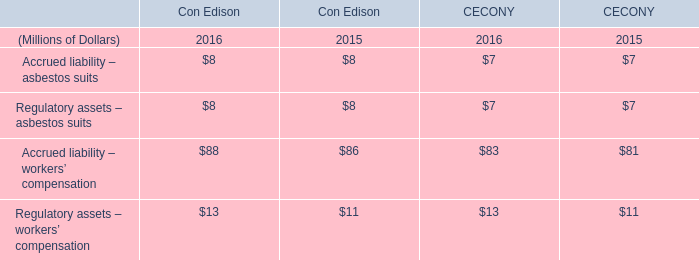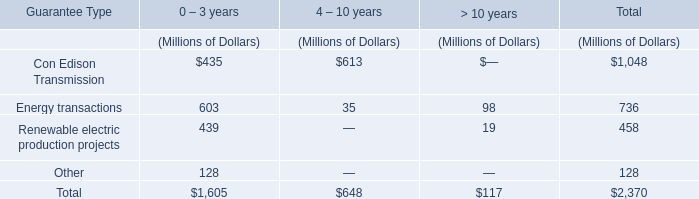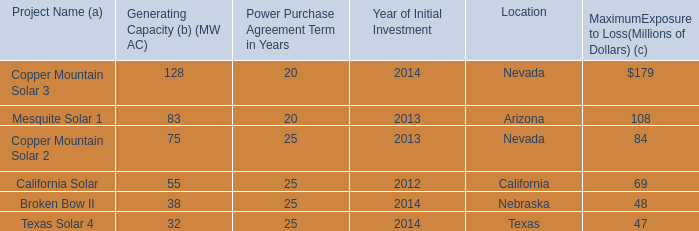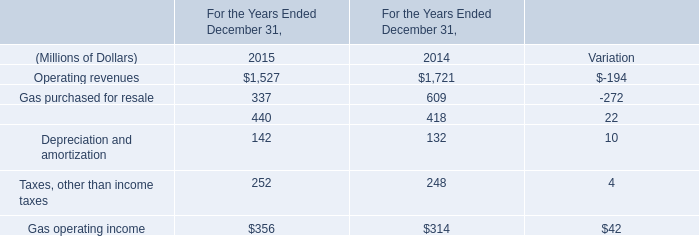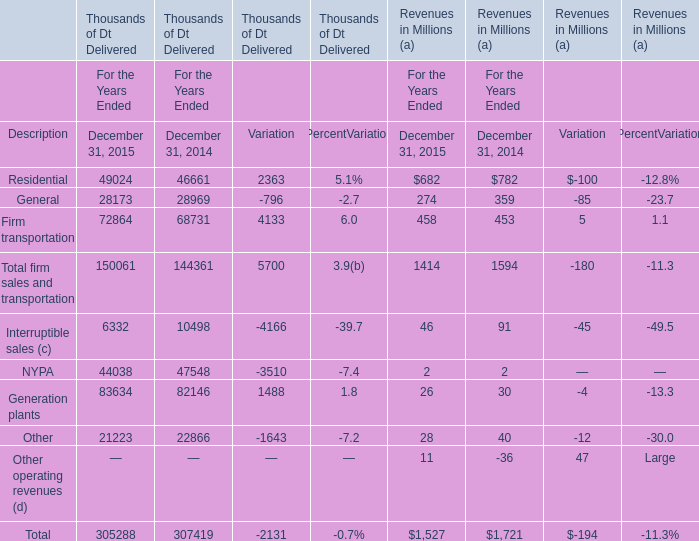What's the total amount of the residential revenue in the years where general revenues is greater than 200 million? (in million) 
Computations: (682 + 782)
Answer: 1464.0. 